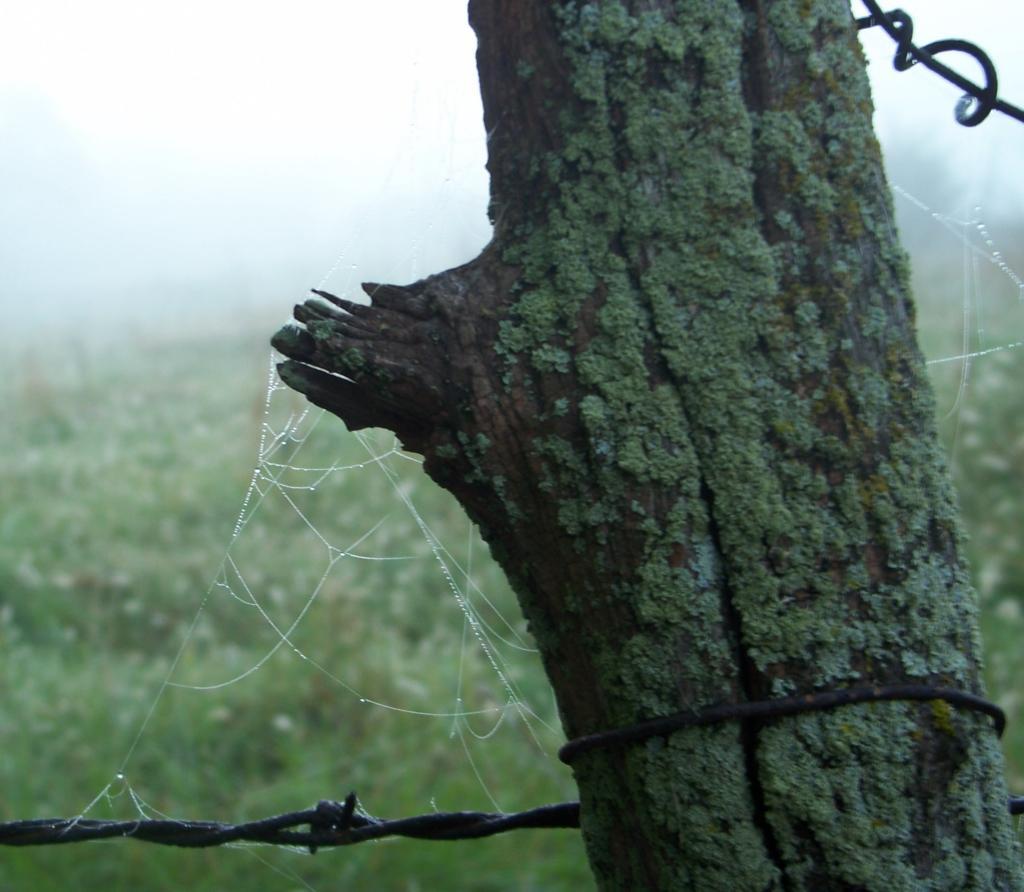Could you give a brief overview of what you see in this image? Here we can see a trunk and there is a blur background with greenery and sky. 